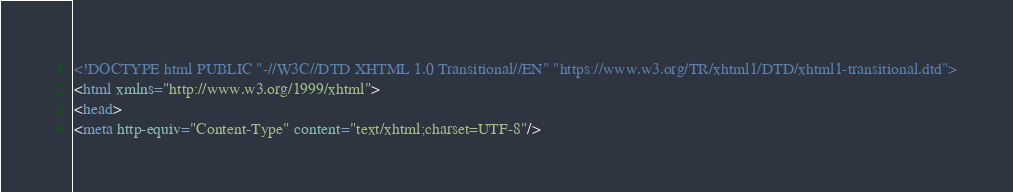Convert code to text. <code><loc_0><loc_0><loc_500><loc_500><_HTML_><!DOCTYPE html PUBLIC "-//W3C//DTD XHTML 1.0 Transitional//EN" "https://www.w3.org/TR/xhtml1/DTD/xhtml1-transitional.dtd">
<html xmlns="http://www.w3.org/1999/xhtml">
<head>
<meta http-equiv="Content-Type" content="text/xhtml;charset=UTF-8"/></code> 